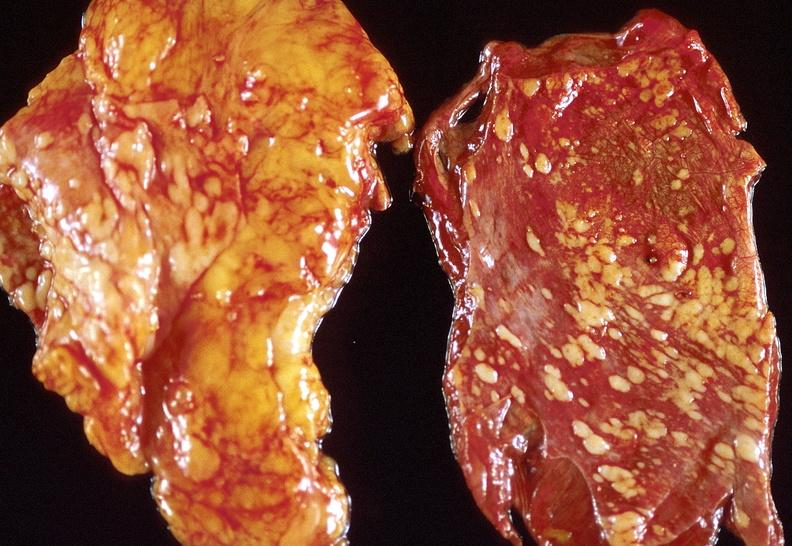what is present?
Answer the question using a single word or phrase. Respiratory 